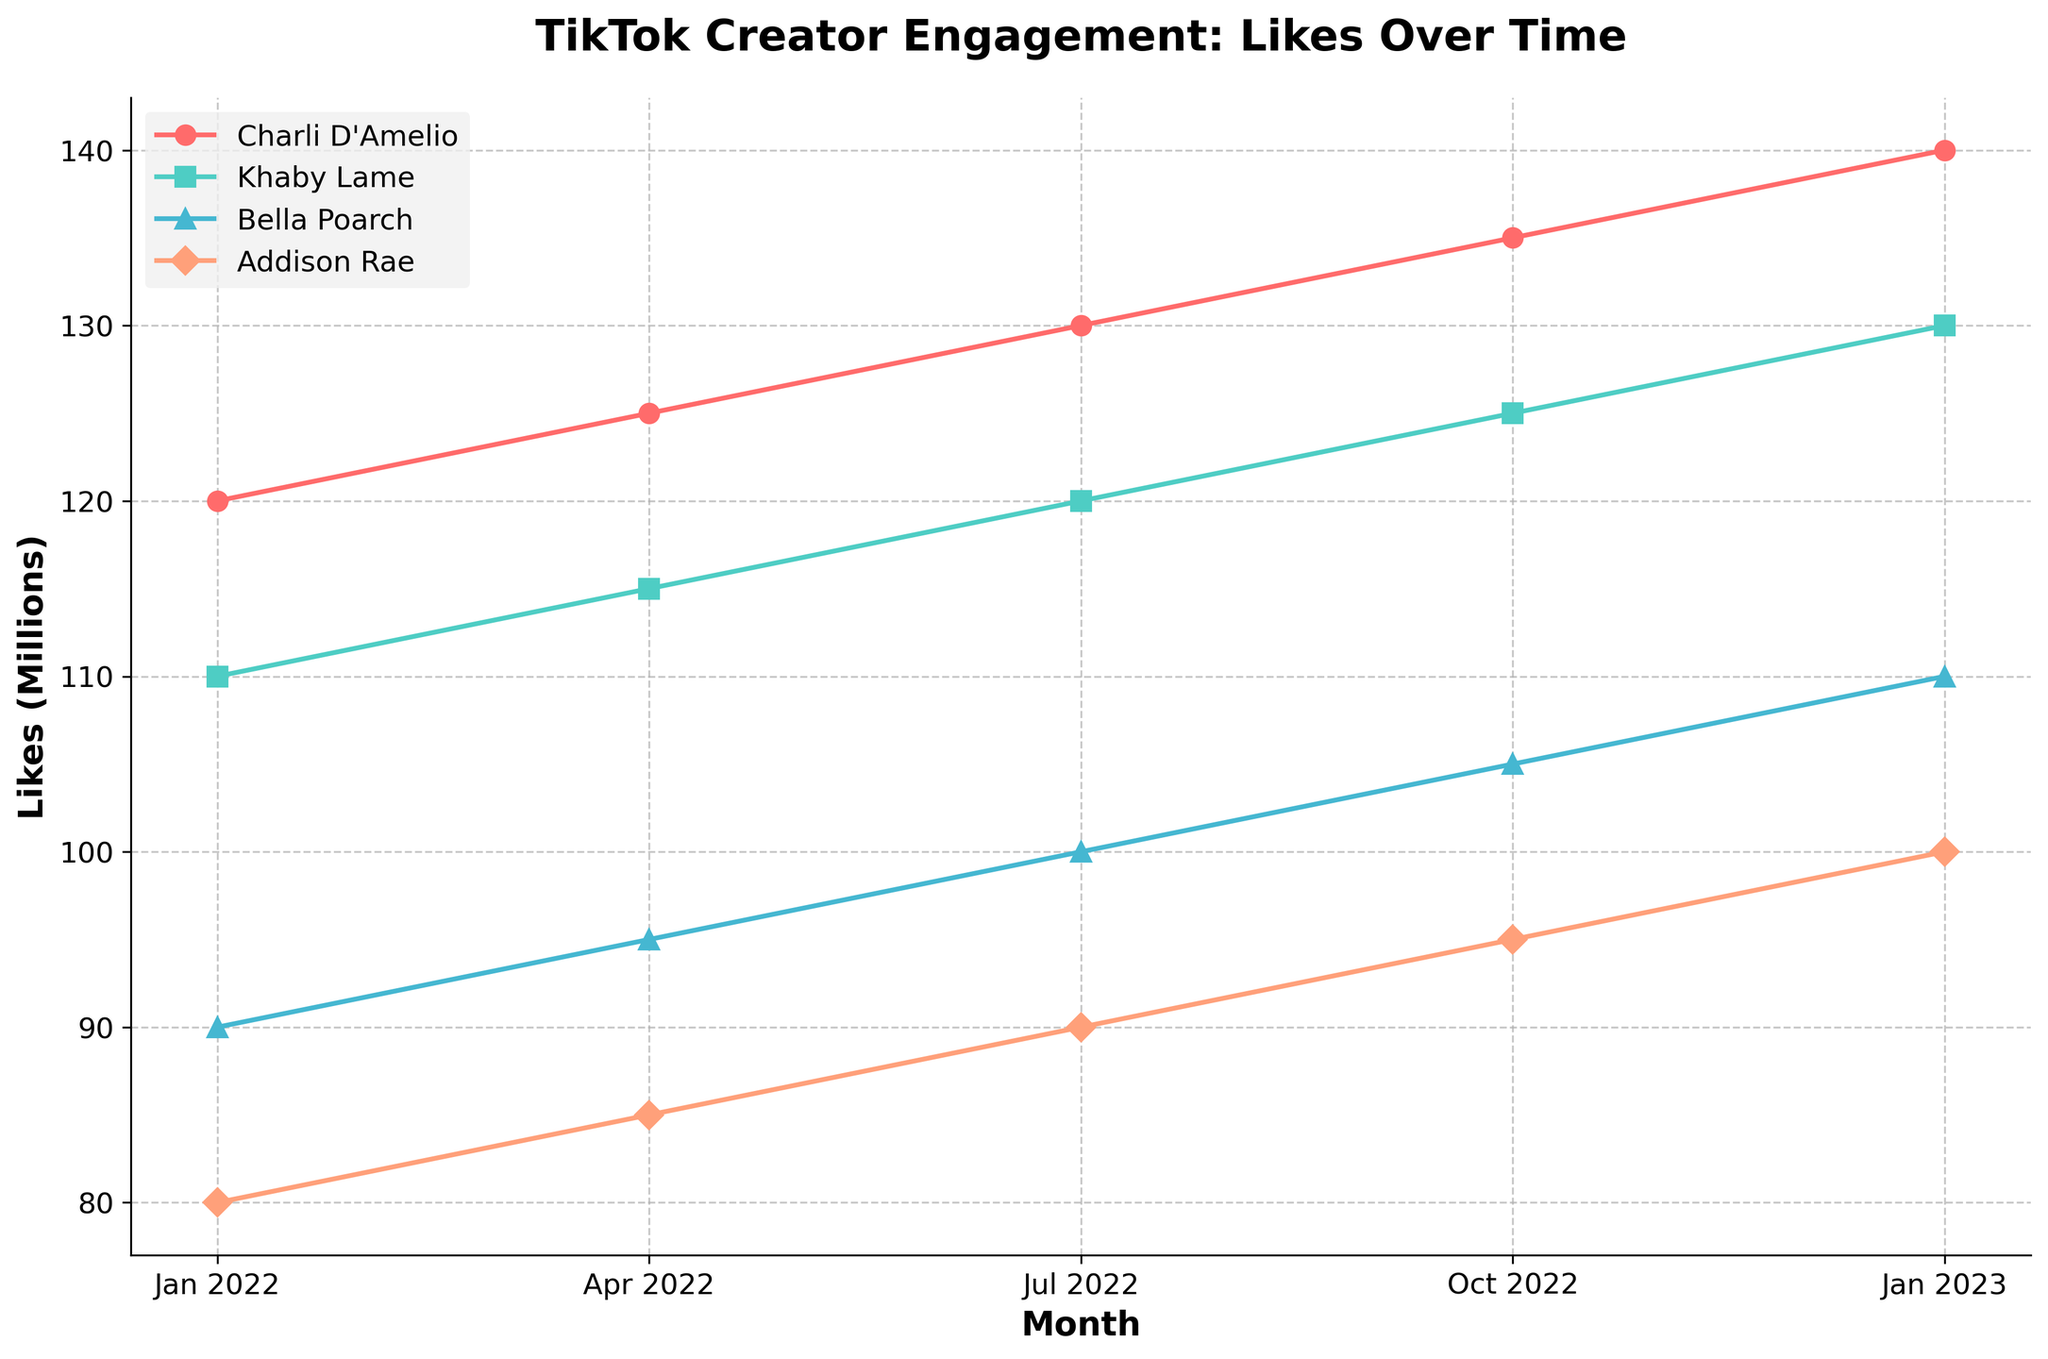What is the overall trend in likes for Charli D'Amelio over the past year? Looking at the chart, Charli D'Amelio's likes are consistently increasing over each quarter from January 2022 to January 2023.
Answer: Increasing Who had the highest number of likes in January 2023? The plot shows that Charli D'Amelio has the highest number of likes in January 2023, as indicated by the topmost line.
Answer: Charli D'Amelio Between April 2022 and July 2022, which creator saw the biggest increase in likes? We need to look at the difference in the height of the lines between April 2022 and July 2022 for each creator. Charli D'Amelio's likes increased from 125 to 130 million (5 million). Khaby Lame's likes increased from 115 to 120 million (5 million). Bella Poarch's likes increased from 95 to 100 million (5 million). Addison Rae's likes increased from 85 to 90 million (5 million). Since all creators had the same increase, any one of them is correct.
Answer: Any creator (Charli D'Amelio, Khaby Lame, Bella Poarch, Addison Rae) What is the difference in likes between Khaby Lame and Addison Rae in July 2022? From the plot, in July 2022, Khaby Lame has around 120 million likes whereas Addison Rae has around 90 million likes. So, the difference is 120 million - 90 million = 30 million.
Answer: 30 million Which creator had the lowest number of likes in October 2022? In October 2022, Addison Rae's likes are depicted by the line lowest on the y-axis compared to other creators, indicating she had the lowest likes.
Answer: Addison Rae Does Bella Poarch ever surpass Khaby Lame in likes throughout the year? The chart shows that at no point does Bella Poarch's line rise above Khaby Lame's line throughout the year.
Answer: No What color represents Bella Poarch on the chart? Bella Poarch is represented by a distinct color in the chart. Based on the legend and the colored lines, Bella Poarch is depicted in green.
Answer: Green How many millions of likes did Charli D'Amelio have in January 2022? Looking at the chart, Charli D'Amelio's line starts at 120 million likes in January 2022.
Answer: 120 million Which two creators had their lines very close to each other in October 2022? From the chart, the lines representing Khaby Lame and Addison Rae are the closest to each other in October 2022.
Answer: Khaby Lame and Addison Rae 